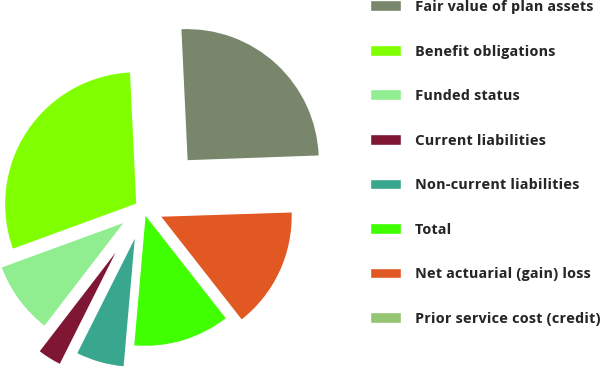<chart> <loc_0><loc_0><loc_500><loc_500><pie_chart><fcel>Fair value of plan assets<fcel>Benefit obligations<fcel>Funded status<fcel>Current liabilities<fcel>Non-current liabilities<fcel>Total<fcel>Net actuarial (gain) loss<fcel>Prior service cost (credit)<nl><fcel>25.18%<fcel>29.82%<fcel>8.99%<fcel>3.03%<fcel>6.01%<fcel>11.96%<fcel>14.94%<fcel>0.06%<nl></chart> 